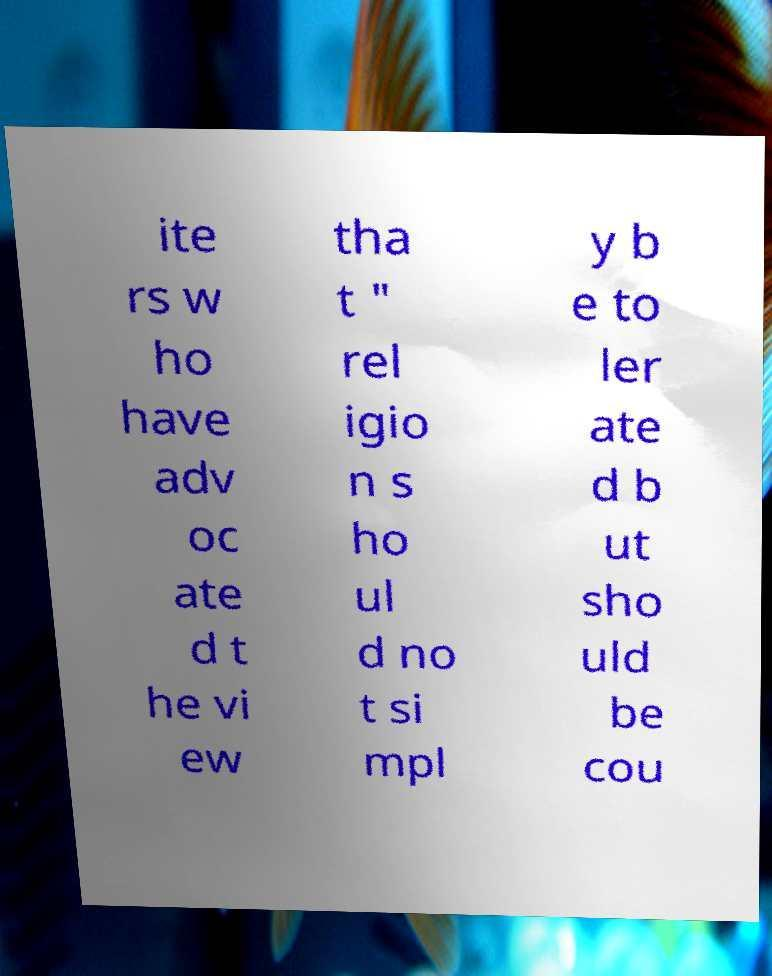I need the written content from this picture converted into text. Can you do that? ite rs w ho have adv oc ate d t he vi ew tha t " rel igio n s ho ul d no t si mpl y b e to ler ate d b ut sho uld be cou 